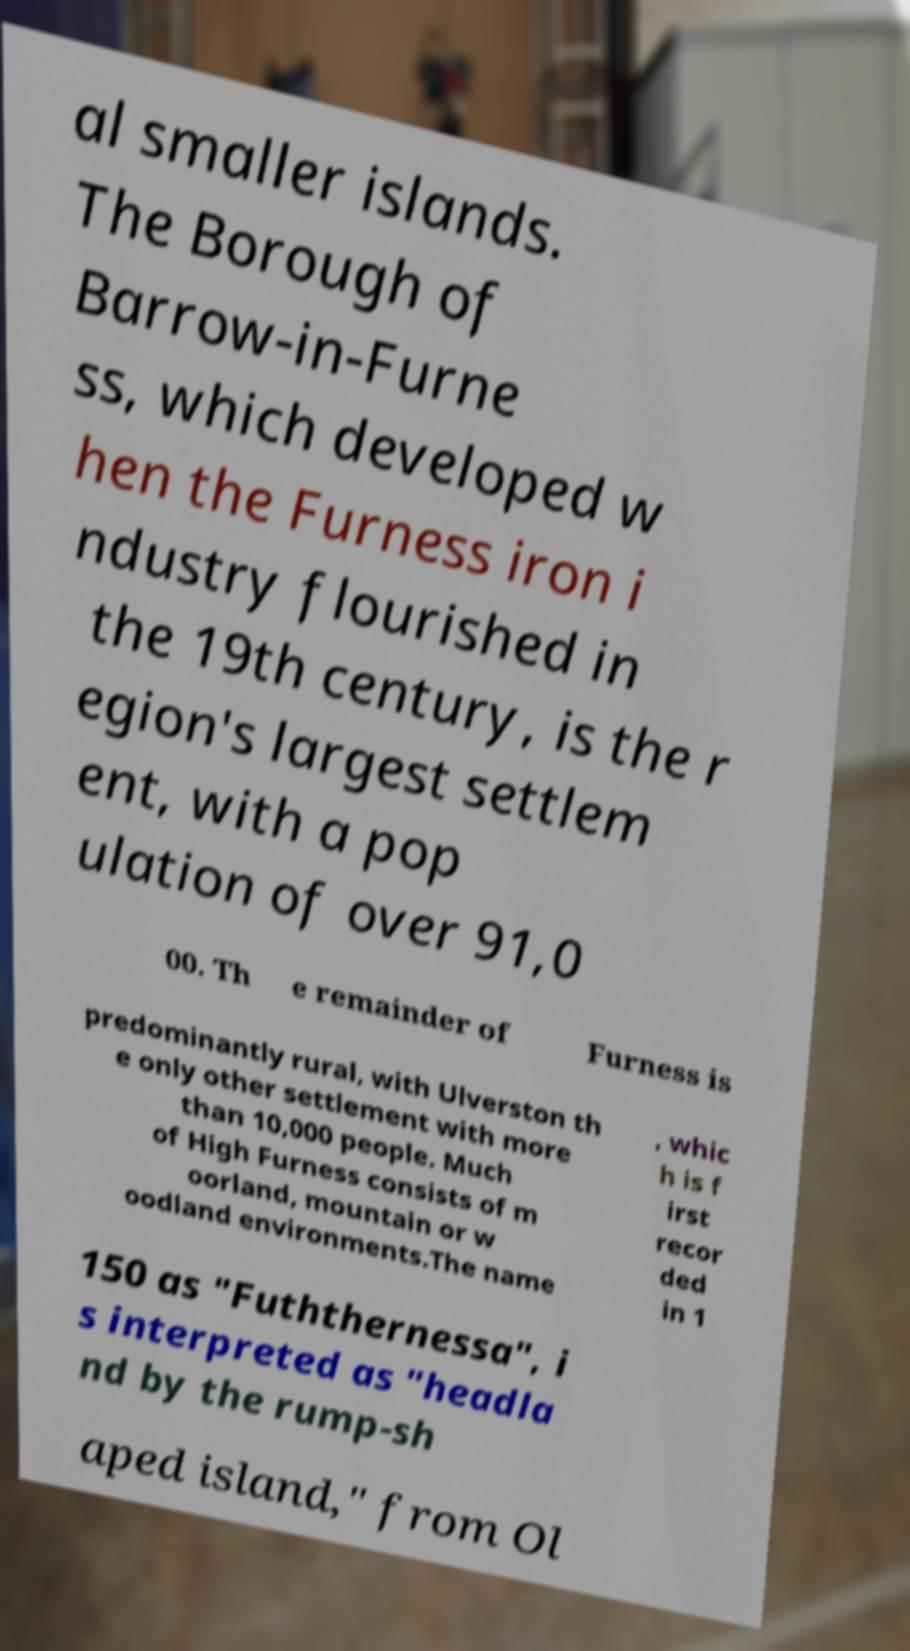For documentation purposes, I need the text within this image transcribed. Could you provide that? al smaller islands. The Borough of Barrow-in-Furne ss, which developed w hen the Furness iron i ndustry flourished in the 19th century, is the r egion's largest settlem ent, with a pop ulation of over 91,0 00. Th e remainder of Furness is predominantly rural, with Ulverston th e only other settlement with more than 10,000 people. Much of High Furness consists of m oorland, mountain or w oodland environments.The name , whic h is f irst recor ded in 1 150 as "Fuththernessa", i s interpreted as "headla nd by the rump-sh aped island," from Ol 